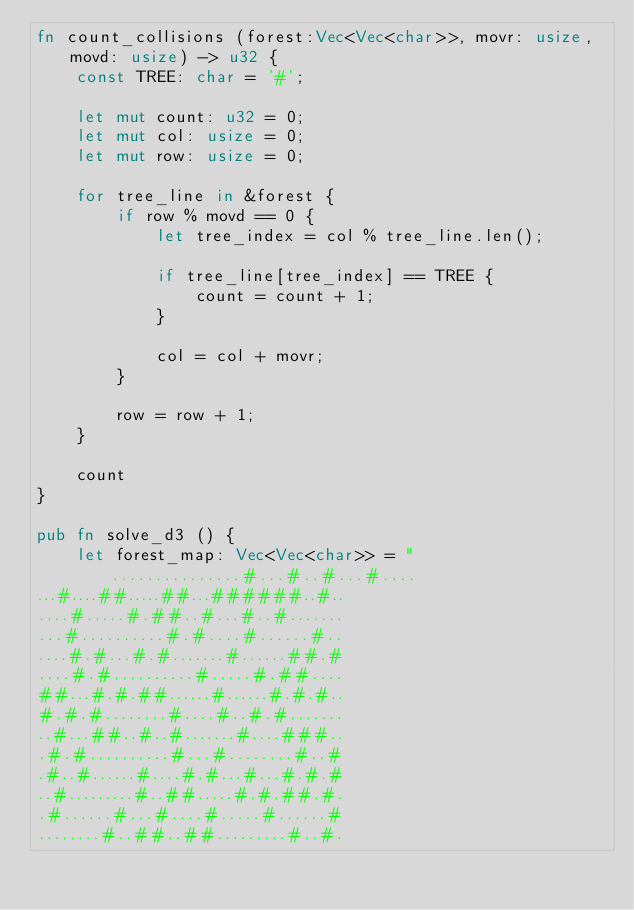<code> <loc_0><loc_0><loc_500><loc_500><_Rust_>fn count_collisions (forest:Vec<Vec<char>>, movr: usize, movd: usize) -> u32 {
    const TREE: char = '#';

    let mut count: u32 = 0;
    let mut col: usize = 0;
    let mut row: usize = 0;

    for tree_line in &forest {
        if row % movd == 0 {
            let tree_index = col % tree_line.len();
            
            if tree_line[tree_index] == TREE {
                count = count + 1;
            }
    
            col = col + movr;
        }

        row = row + 1;
    }

    count 
}

pub fn solve_d3 () {
    let forest_map: Vec<Vec<char>> = "...............#...#..#...#....
...#....##.....##...######..#..
....#.....#.##..#...#..#.......
...#..........#.#....#......#..
....#.#...#.#.......#......##.#
....#.#..........#.....#.##....
##...#.#.##......#......#.#.#..
#.#.#........#....#..#.#.......
..#...##..#..#.......#....###..
.#.#..........#...#........#..#
.#..#......#....#.#...#...#.#.#
..#.........#..##.....#.#.##.#.
.#......#...#....#.....#......#
........#..##..##.........#..#.</code> 